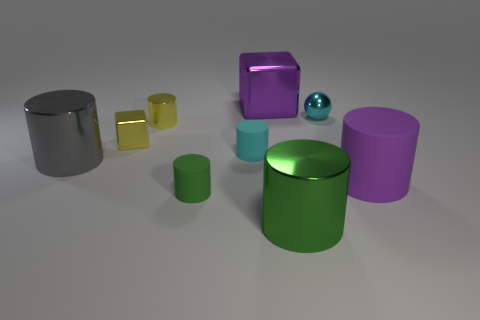What is the size of the matte cylinder that is the same color as the large block?
Make the answer very short. Large. How big is the yellow block?
Give a very brief answer. Small. There is a matte cylinder right of the big thing that is behind the cyan rubber cylinder; is there a small thing that is behind it?
Offer a very short reply. Yes. How many small things are either blue objects or green rubber objects?
Provide a short and direct response. 1. Is there any other thing that has the same color as the big block?
Ensure brevity in your answer.  Yes. There is a cyan object that is on the left side of the sphere; is it the same size as the large gray metal thing?
Make the answer very short. No. The small object right of the cube behind the cyan object that is behind the tiny cyan rubber thing is what color?
Provide a short and direct response. Cyan. What color is the big block?
Keep it short and to the point. Purple. Is the small shiny cylinder the same color as the tiny block?
Offer a terse response. Yes. Is the material of the purple thing behind the large rubber cylinder the same as the tiny cylinder in front of the large rubber object?
Your answer should be compact. No. 